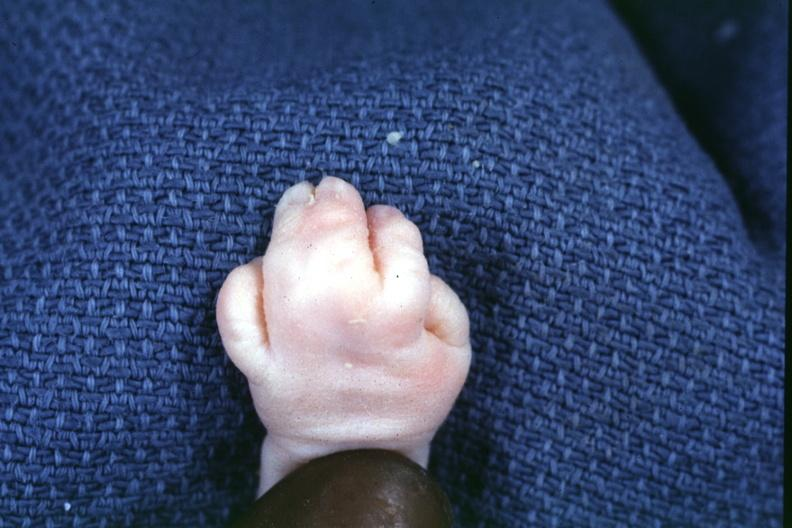what are present?
Answer the question using a single word or phrase. Extremities 